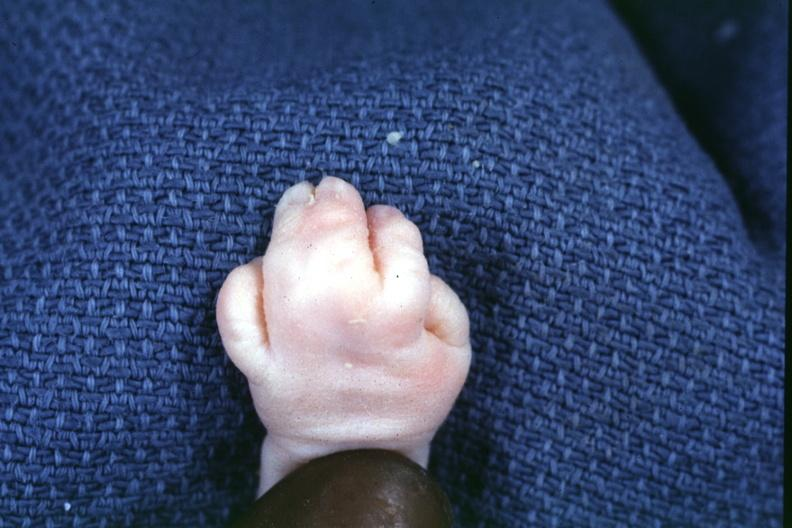what are present?
Answer the question using a single word or phrase. Extremities 